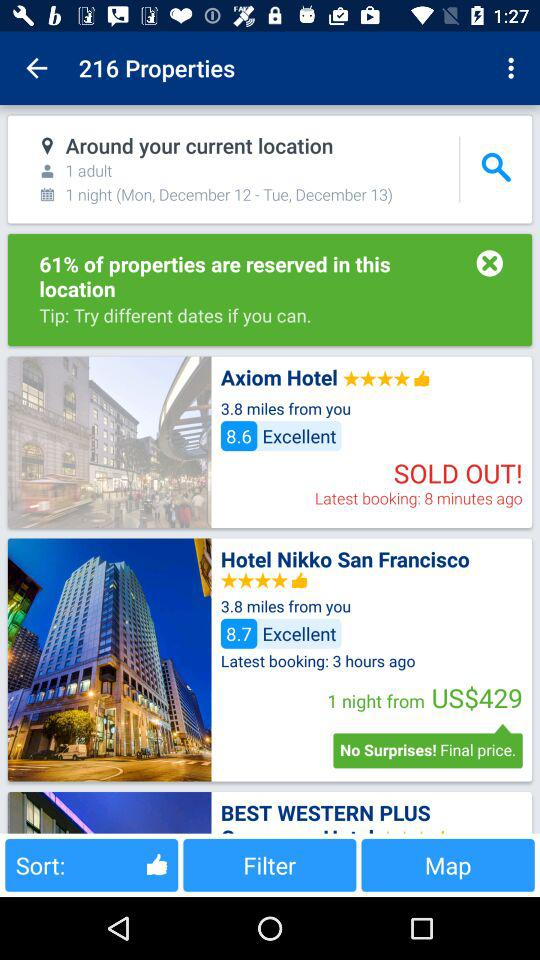What is the review of the Hotel Nikko San Francisco? The review is "Excellent". 